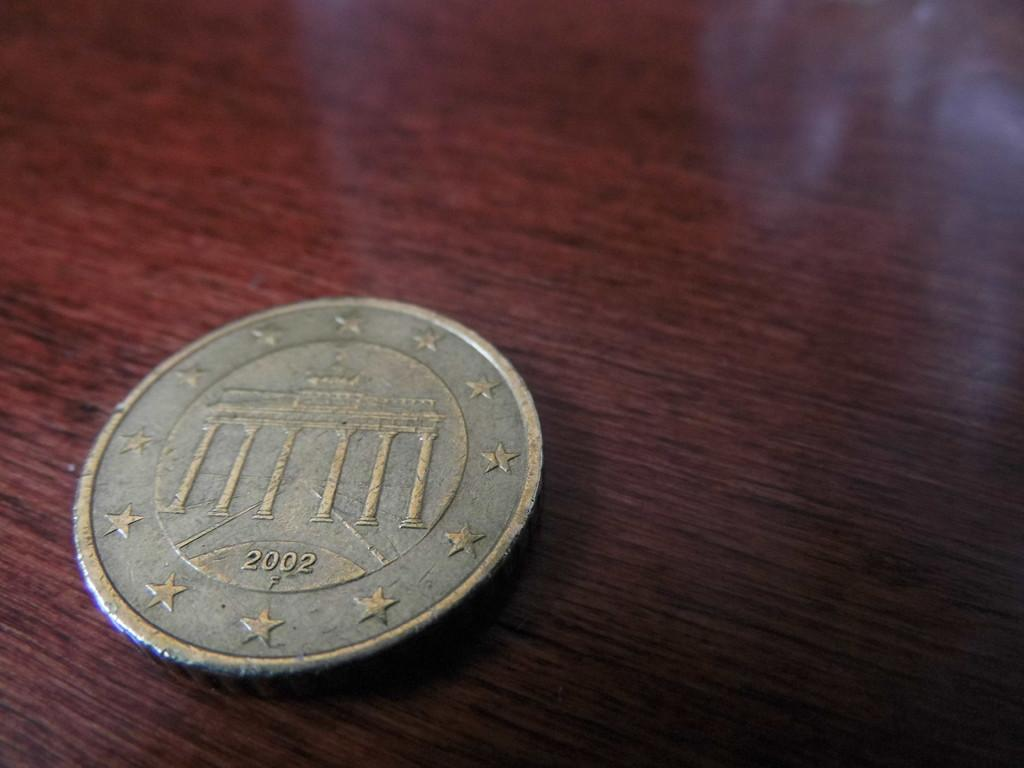Provide a one-sentence caption for the provided image. A worn down silver colored coin from 2002 with stars around the perimeter. 